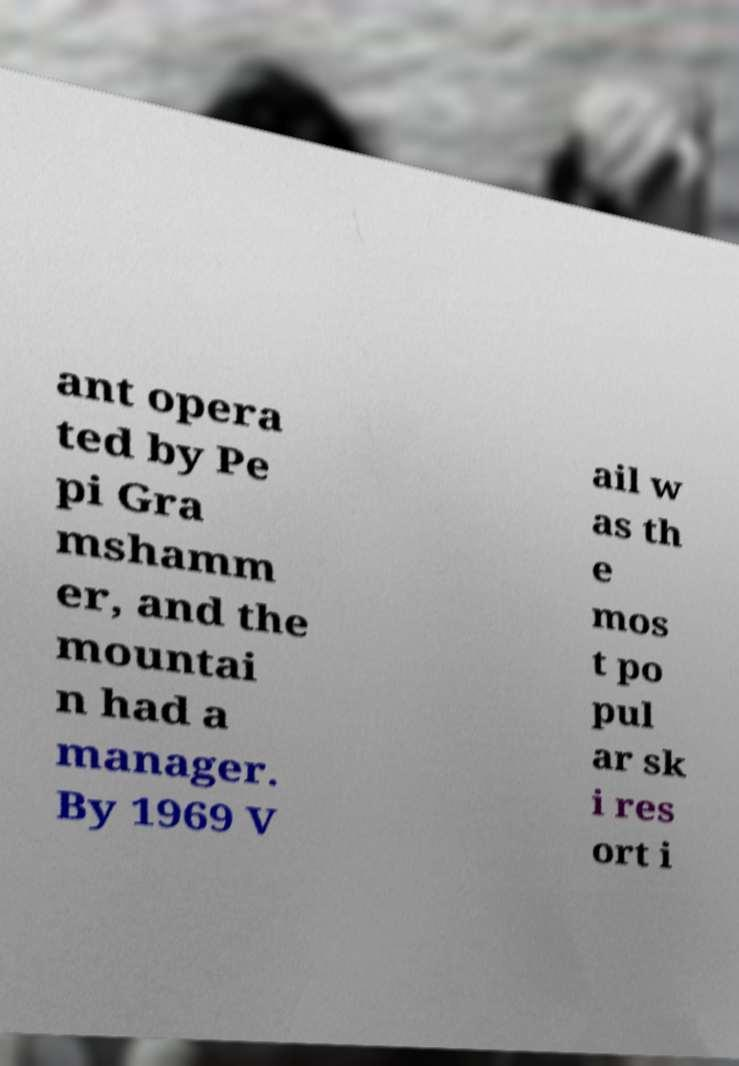Can you read and provide the text displayed in the image?This photo seems to have some interesting text. Can you extract and type it out for me? ant opera ted by Pe pi Gra mshamm er, and the mountai n had a manager. By 1969 V ail w as th e mos t po pul ar sk i res ort i 